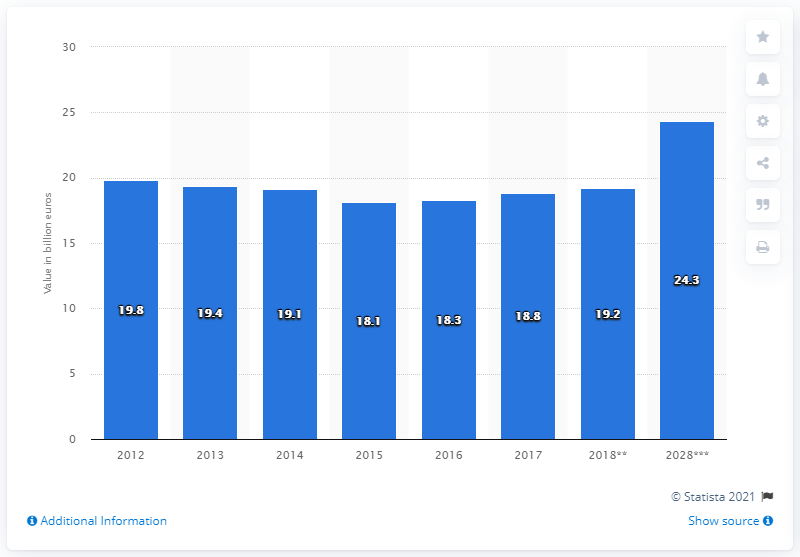Point out several critical features in this image. According to estimates, the travel and tourism industry is expected to contribute 19.2% to Finland's Gross Domestic Product in 2020. 